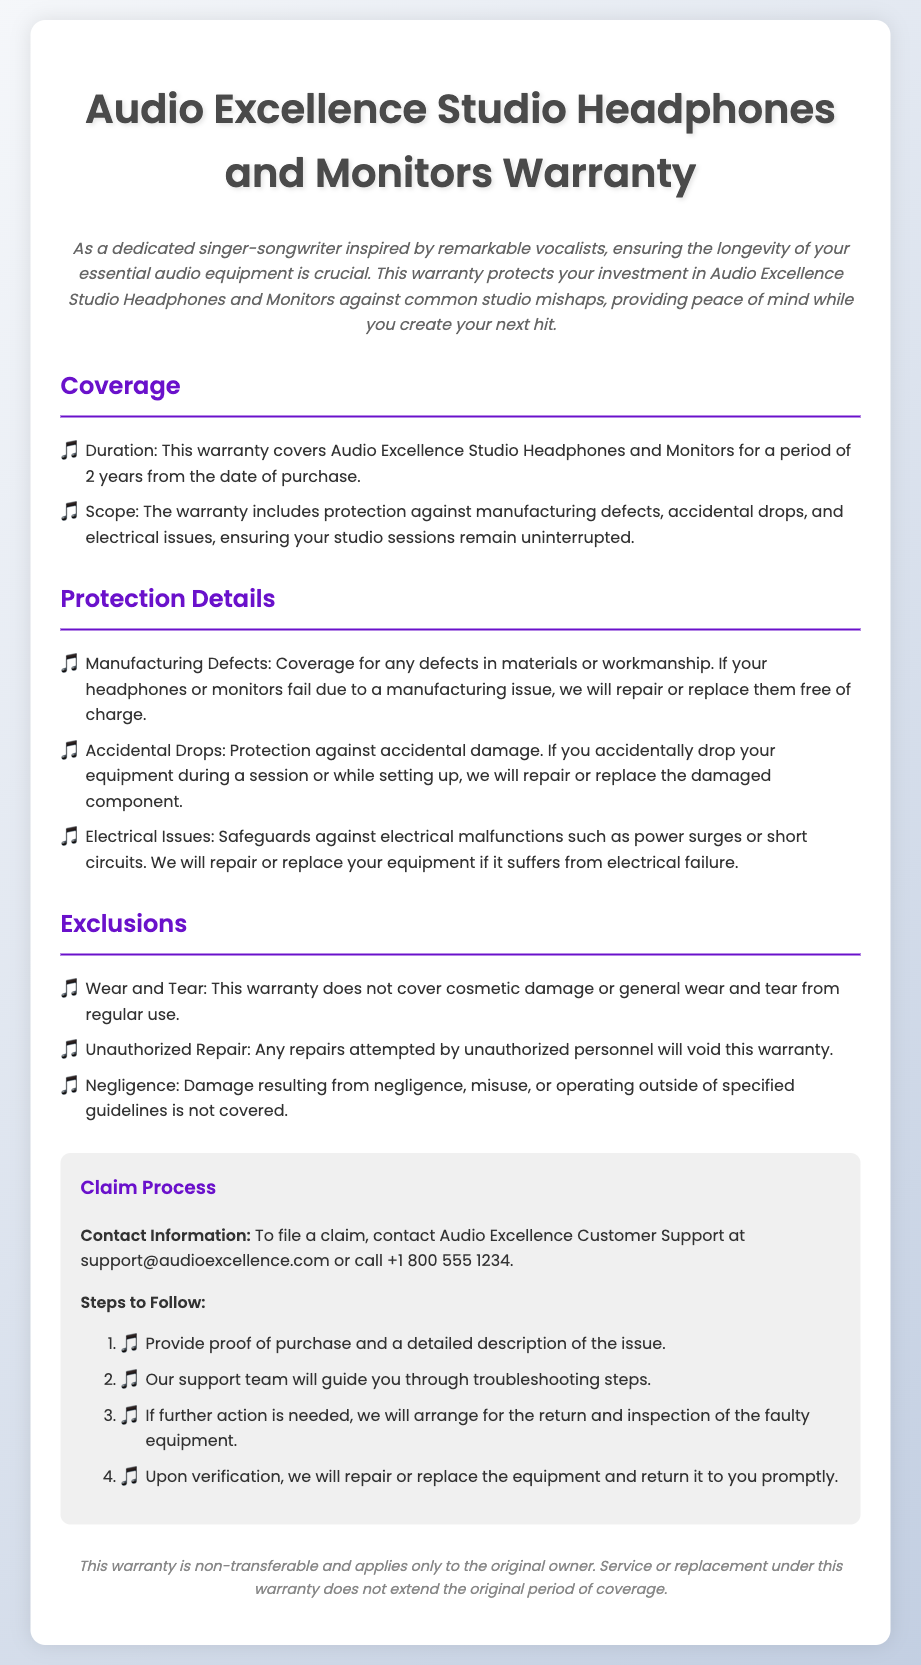What is the duration of the warranty? The warranty covers the headphones and monitors for a period of 2 years from the date of purchase.
Answer: 2 years What does the warranty protect against? The warranty includes protection against manufacturing defects, accidental drops, and electrical issues.
Answer: manufacturing defects, accidental drops, electrical issues What type of damage is not covered by the warranty? The warranty does not cover cosmetic damage or general wear and tear from regular use.
Answer: cosmetic damage, general wear and tear What should you provide to file a claim? You need to provide proof of purchase and a detailed description of the issue.
Answer: proof of purchase, detailed description What is the claim contact email? The claim contact email is provided for customer support inquiries.
Answer: support@audioexcellence.com If you accidentally drop your equipment, what does the warranty cover? The warranty provides protection against accidental damage like drops during a session or while setting up.
Answer: accidental damage Who is the warranty applicable to? This warranty is non-transferable and applies only to the original owner.
Answer: original owner What is excluded if you attempt unauthorized repairs? Any repairs attempted by unauthorized personnel will void this warranty.
Answer: void this warranty 